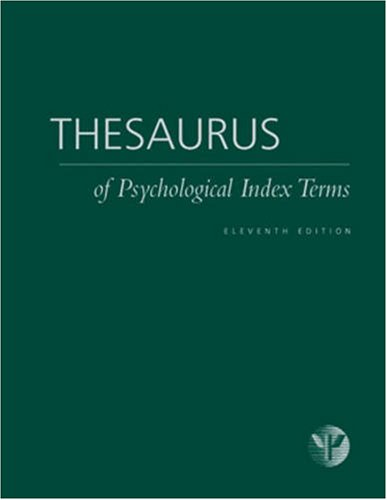What is the title of this book? The title of the book displayed is 'Thesaurus of Psychological Index Terms', which is an extensive reference guide focusing on terminology used in psychology. 